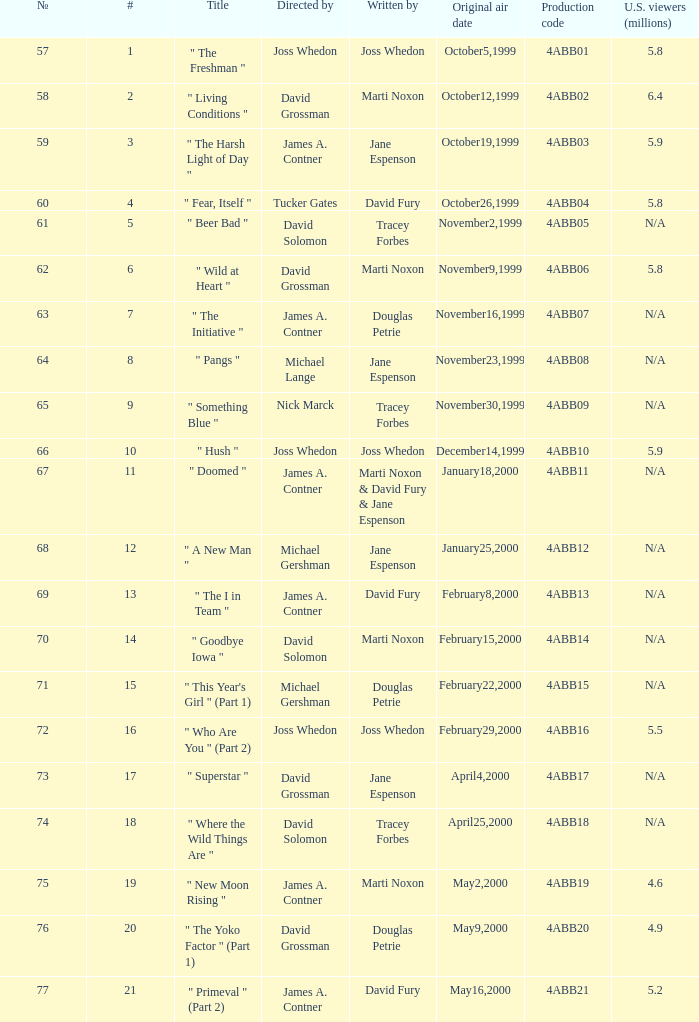What is the season 4 # for the production code of 4abb07? 7.0. 